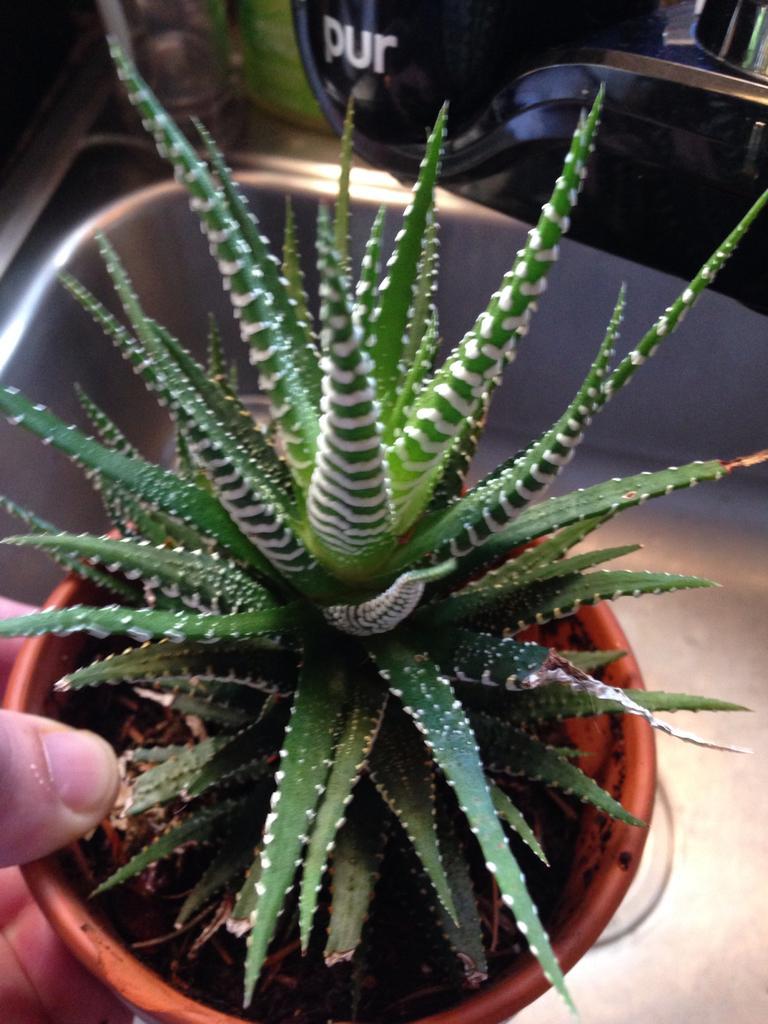How would you summarize this image in a sentence or two? In the center of the image there is a houseplant in human hands. In the background there is a sink. 